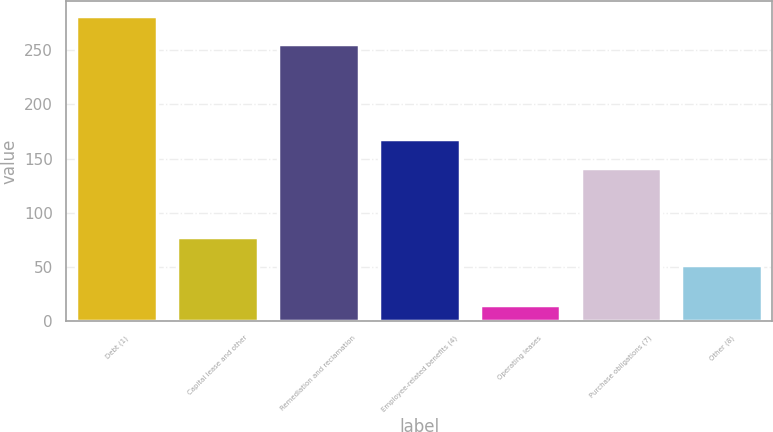Convert chart to OTSL. <chart><loc_0><loc_0><loc_500><loc_500><bar_chart><fcel>Debt (1)<fcel>Capital lease and other<fcel>Remediation and reclamation<fcel>Employee-related benefits (4)<fcel>Operating leases<fcel>Purchase obligations (7)<fcel>Other (8)<nl><fcel>281.2<fcel>78.2<fcel>255<fcel>168<fcel>15<fcel>141<fcel>52<nl></chart> 